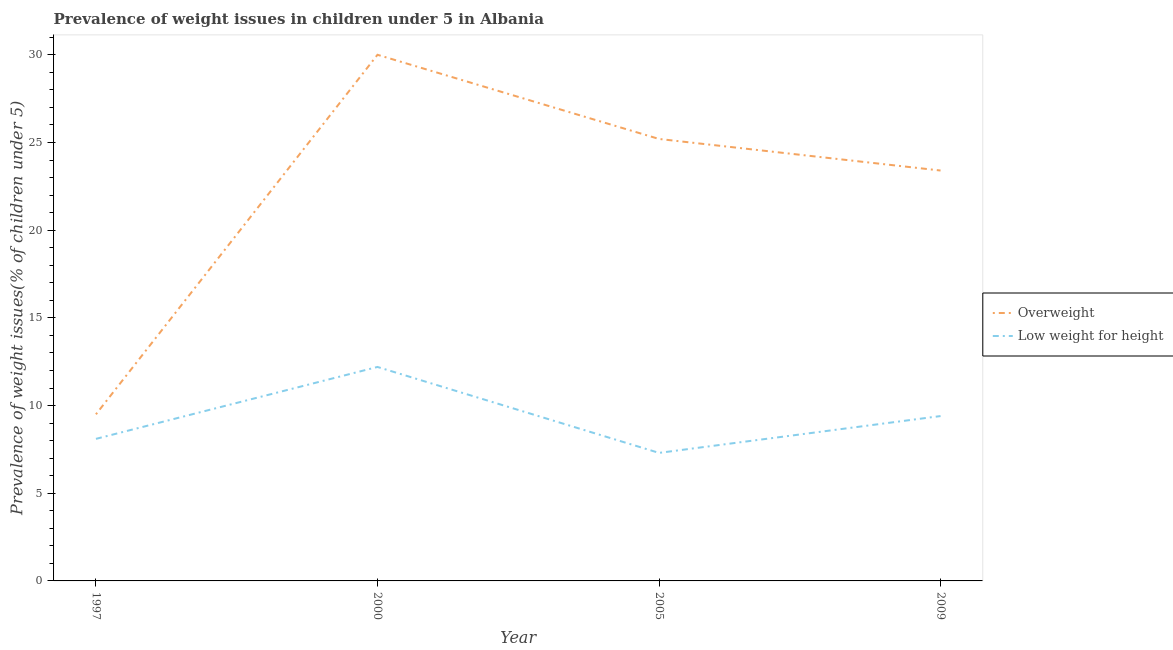How many different coloured lines are there?
Ensure brevity in your answer.  2. Does the line corresponding to percentage of underweight children intersect with the line corresponding to percentage of overweight children?
Keep it short and to the point. No. Is the number of lines equal to the number of legend labels?
Keep it short and to the point. Yes. What is the percentage of underweight children in 2005?
Offer a very short reply. 7.3. Across all years, what is the maximum percentage of underweight children?
Keep it short and to the point. 12.2. Across all years, what is the minimum percentage of underweight children?
Offer a terse response. 7.3. In which year was the percentage of underweight children maximum?
Ensure brevity in your answer.  2000. In which year was the percentage of underweight children minimum?
Your answer should be compact. 2005. What is the total percentage of underweight children in the graph?
Make the answer very short. 37. What is the difference between the percentage of overweight children in 1997 and that in 2009?
Provide a short and direct response. -13.9. What is the difference between the percentage of overweight children in 2009 and the percentage of underweight children in 2000?
Give a very brief answer. 11.2. What is the average percentage of underweight children per year?
Provide a succinct answer. 9.25. In the year 2000, what is the difference between the percentage of overweight children and percentage of underweight children?
Ensure brevity in your answer.  17.8. In how many years, is the percentage of overweight children greater than 2 %?
Make the answer very short. 4. What is the ratio of the percentage of underweight children in 2000 to that in 2005?
Provide a succinct answer. 1.67. Is the percentage of overweight children in 2000 less than that in 2005?
Ensure brevity in your answer.  No. What is the difference between the highest and the second highest percentage of underweight children?
Make the answer very short. 2.8. What is the difference between the highest and the lowest percentage of underweight children?
Your response must be concise. 4.9. Is the sum of the percentage of overweight children in 1997 and 2009 greater than the maximum percentage of underweight children across all years?
Offer a very short reply. Yes. Does the percentage of underweight children monotonically increase over the years?
Ensure brevity in your answer.  No. Is the percentage of underweight children strictly greater than the percentage of overweight children over the years?
Your response must be concise. No. Is the percentage of underweight children strictly less than the percentage of overweight children over the years?
Your answer should be very brief. Yes. How many lines are there?
Give a very brief answer. 2. How many years are there in the graph?
Your answer should be compact. 4. Does the graph contain grids?
Give a very brief answer. No. Where does the legend appear in the graph?
Your response must be concise. Center right. How are the legend labels stacked?
Offer a terse response. Vertical. What is the title of the graph?
Ensure brevity in your answer.  Prevalence of weight issues in children under 5 in Albania. Does "Commercial service exports" appear as one of the legend labels in the graph?
Provide a succinct answer. No. What is the label or title of the X-axis?
Give a very brief answer. Year. What is the label or title of the Y-axis?
Offer a terse response. Prevalence of weight issues(% of children under 5). What is the Prevalence of weight issues(% of children under 5) in Overweight in 1997?
Your response must be concise. 9.5. What is the Prevalence of weight issues(% of children under 5) in Low weight for height in 1997?
Your answer should be very brief. 8.1. What is the Prevalence of weight issues(% of children under 5) in Low weight for height in 2000?
Ensure brevity in your answer.  12.2. What is the Prevalence of weight issues(% of children under 5) of Overweight in 2005?
Keep it short and to the point. 25.2. What is the Prevalence of weight issues(% of children under 5) in Low weight for height in 2005?
Your answer should be very brief. 7.3. What is the Prevalence of weight issues(% of children under 5) in Overweight in 2009?
Make the answer very short. 23.4. What is the Prevalence of weight issues(% of children under 5) in Low weight for height in 2009?
Provide a succinct answer. 9.4. Across all years, what is the maximum Prevalence of weight issues(% of children under 5) in Overweight?
Provide a succinct answer. 30. Across all years, what is the maximum Prevalence of weight issues(% of children under 5) in Low weight for height?
Provide a succinct answer. 12.2. Across all years, what is the minimum Prevalence of weight issues(% of children under 5) in Overweight?
Offer a very short reply. 9.5. Across all years, what is the minimum Prevalence of weight issues(% of children under 5) in Low weight for height?
Offer a very short reply. 7.3. What is the total Prevalence of weight issues(% of children under 5) in Overweight in the graph?
Your answer should be very brief. 88.1. What is the difference between the Prevalence of weight issues(% of children under 5) in Overweight in 1997 and that in 2000?
Keep it short and to the point. -20.5. What is the difference between the Prevalence of weight issues(% of children under 5) in Low weight for height in 1997 and that in 2000?
Ensure brevity in your answer.  -4.1. What is the difference between the Prevalence of weight issues(% of children under 5) in Overweight in 1997 and that in 2005?
Your answer should be very brief. -15.7. What is the difference between the Prevalence of weight issues(% of children under 5) of Low weight for height in 1997 and that in 2009?
Give a very brief answer. -1.3. What is the difference between the Prevalence of weight issues(% of children under 5) in Overweight in 2000 and that in 2005?
Provide a succinct answer. 4.8. What is the difference between the Prevalence of weight issues(% of children under 5) of Overweight in 2000 and that in 2009?
Provide a short and direct response. 6.6. What is the difference between the Prevalence of weight issues(% of children under 5) in Overweight in 2005 and that in 2009?
Provide a short and direct response. 1.8. What is the difference between the Prevalence of weight issues(% of children under 5) in Low weight for height in 2005 and that in 2009?
Your answer should be very brief. -2.1. What is the difference between the Prevalence of weight issues(% of children under 5) of Overweight in 1997 and the Prevalence of weight issues(% of children under 5) of Low weight for height in 2000?
Ensure brevity in your answer.  -2.7. What is the difference between the Prevalence of weight issues(% of children under 5) in Overweight in 1997 and the Prevalence of weight issues(% of children under 5) in Low weight for height in 2009?
Offer a terse response. 0.1. What is the difference between the Prevalence of weight issues(% of children under 5) in Overweight in 2000 and the Prevalence of weight issues(% of children under 5) in Low weight for height in 2005?
Your response must be concise. 22.7. What is the difference between the Prevalence of weight issues(% of children under 5) in Overweight in 2000 and the Prevalence of weight issues(% of children under 5) in Low weight for height in 2009?
Offer a very short reply. 20.6. What is the difference between the Prevalence of weight issues(% of children under 5) of Overweight in 2005 and the Prevalence of weight issues(% of children under 5) of Low weight for height in 2009?
Provide a succinct answer. 15.8. What is the average Prevalence of weight issues(% of children under 5) in Overweight per year?
Your answer should be compact. 22.02. What is the average Prevalence of weight issues(% of children under 5) in Low weight for height per year?
Provide a succinct answer. 9.25. In the year 2009, what is the difference between the Prevalence of weight issues(% of children under 5) in Overweight and Prevalence of weight issues(% of children under 5) in Low weight for height?
Provide a short and direct response. 14. What is the ratio of the Prevalence of weight issues(% of children under 5) in Overweight in 1997 to that in 2000?
Provide a short and direct response. 0.32. What is the ratio of the Prevalence of weight issues(% of children under 5) of Low weight for height in 1997 to that in 2000?
Offer a terse response. 0.66. What is the ratio of the Prevalence of weight issues(% of children under 5) of Overweight in 1997 to that in 2005?
Offer a very short reply. 0.38. What is the ratio of the Prevalence of weight issues(% of children under 5) of Low weight for height in 1997 to that in 2005?
Your answer should be compact. 1.11. What is the ratio of the Prevalence of weight issues(% of children under 5) of Overweight in 1997 to that in 2009?
Ensure brevity in your answer.  0.41. What is the ratio of the Prevalence of weight issues(% of children under 5) in Low weight for height in 1997 to that in 2009?
Ensure brevity in your answer.  0.86. What is the ratio of the Prevalence of weight issues(% of children under 5) of Overweight in 2000 to that in 2005?
Your response must be concise. 1.19. What is the ratio of the Prevalence of weight issues(% of children under 5) in Low weight for height in 2000 to that in 2005?
Give a very brief answer. 1.67. What is the ratio of the Prevalence of weight issues(% of children under 5) of Overweight in 2000 to that in 2009?
Your response must be concise. 1.28. What is the ratio of the Prevalence of weight issues(% of children under 5) in Low weight for height in 2000 to that in 2009?
Your response must be concise. 1.3. What is the ratio of the Prevalence of weight issues(% of children under 5) of Low weight for height in 2005 to that in 2009?
Give a very brief answer. 0.78. 